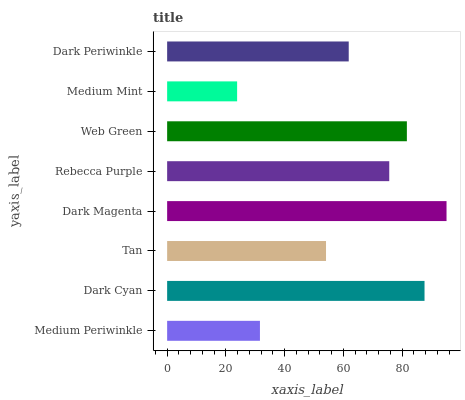Is Medium Mint the minimum?
Answer yes or no. Yes. Is Dark Magenta the maximum?
Answer yes or no. Yes. Is Dark Cyan the minimum?
Answer yes or no. No. Is Dark Cyan the maximum?
Answer yes or no. No. Is Dark Cyan greater than Medium Periwinkle?
Answer yes or no. Yes. Is Medium Periwinkle less than Dark Cyan?
Answer yes or no. Yes. Is Medium Periwinkle greater than Dark Cyan?
Answer yes or no. No. Is Dark Cyan less than Medium Periwinkle?
Answer yes or no. No. Is Rebecca Purple the high median?
Answer yes or no. Yes. Is Dark Periwinkle the low median?
Answer yes or no. Yes. Is Web Green the high median?
Answer yes or no. No. Is Dark Magenta the low median?
Answer yes or no. No. 